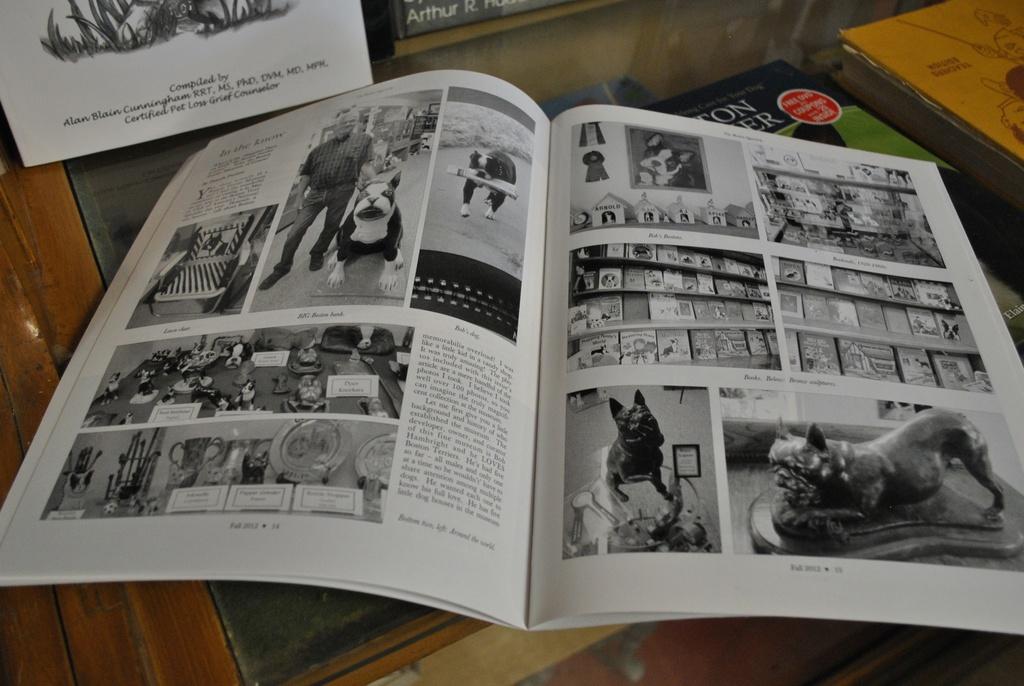What is the name of the author on the white book at the top?
Keep it short and to the point. Alan blain cunningham. 